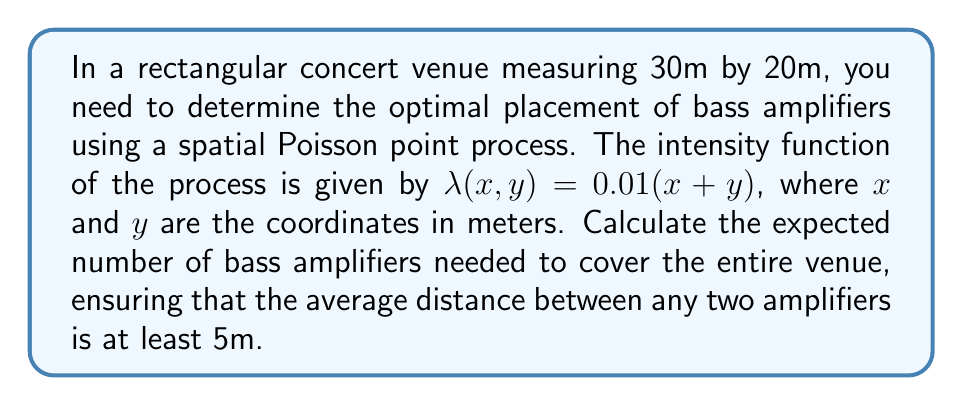Can you solve this math problem? To solve this problem, we'll follow these steps:

1) First, we need to calculate the expected number of points (bass amplifiers) in the entire venue. This is given by the integral of the intensity function over the region:

   $$E[N] = \int_0^{30}\int_0^{20} 0.01(x+y) dy dx$$

2) Solving this double integral:

   $$E[N] = 0.01 \int_0^{30} (20x + \frac{20^2}{2}) dx$$
   $$= 0.01 (10x^2 + 200x)|_0^{30}$$
   $$= 0.01 (9000 + 6000) = 150$$

3) Now, to ensure that the average distance between any two amplifiers is at least 5m, we need to consider the intensity of the process. The average area per point in a Poisson process is approximately $1/\lambda$, where $\lambda$ is the average intensity.

4) The average intensity over the venue is:

   $$\bar{\lambda} = \frac{150}{30 * 20} = 0.25 \text{ points/m}^2$$

5) For a minimum distance of 5m between points, each point should cover an area of at least $\pi r^2 = \pi (2.5)^2 \approx 19.6 \text{ m}^2$.

6) This means we need approximately one point per 19.6 $\text{m}^2$, or an intensity of $1/19.6 \approx 0.051 \text{ points/m}^2$.

7) To achieve this, we need to thin our original process. The thinning factor is:

   $$\frac{0.051}{0.25} \approx 0.204$$

8) Therefore, the expected number of amplifiers after thinning is:

   $$150 * 0.204 \approx 30.6$$

Rounding up to ensure coverage, we need 31 bass amplifiers.
Answer: 31 bass amplifiers 